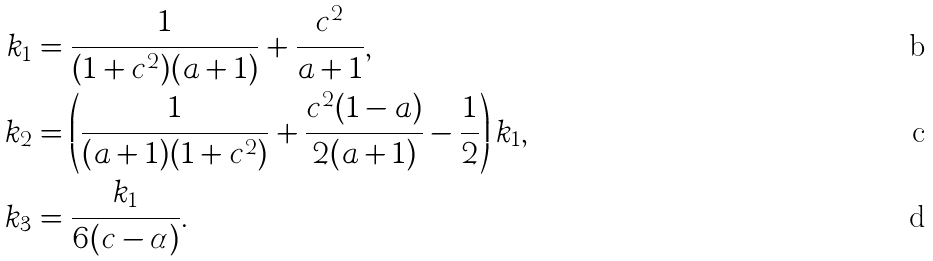Convert formula to latex. <formula><loc_0><loc_0><loc_500><loc_500>k _ { 1 } & = \frac { 1 } { ( 1 + c ^ { 2 } ) ( a + 1 ) } + \frac { c ^ { 2 } } { a + 1 } , \\ k _ { 2 } & = \left ( \frac { 1 } { ( a + 1 ) ( 1 + c ^ { 2 } ) } + \frac { c ^ { 2 } ( 1 - a ) } { 2 ( a + 1 ) } - \frac { 1 } { 2 } \right ) k _ { 1 } , \\ k _ { 3 } & = \frac { k _ { 1 } } { 6 ( c - \alpha ) } .</formula> 